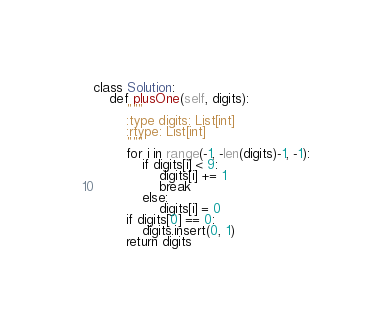<code> <loc_0><loc_0><loc_500><loc_500><_Python_>class Solution:
    def plusOne(self, digits):
        """
        :type digits: List[int]
        :rtype: List[int]
        """
        for i in range(-1, -len(digits)-1, -1):
            if digits[i] < 9:
                digits[i] += 1
                break
            else:
                digits[i] = 0
        if digits[0] == 0:
            digits.insert(0, 1)
        return digits
</code> 